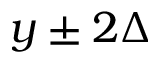<formula> <loc_0><loc_0><loc_500><loc_500>y \pm 2 \Delta</formula> 